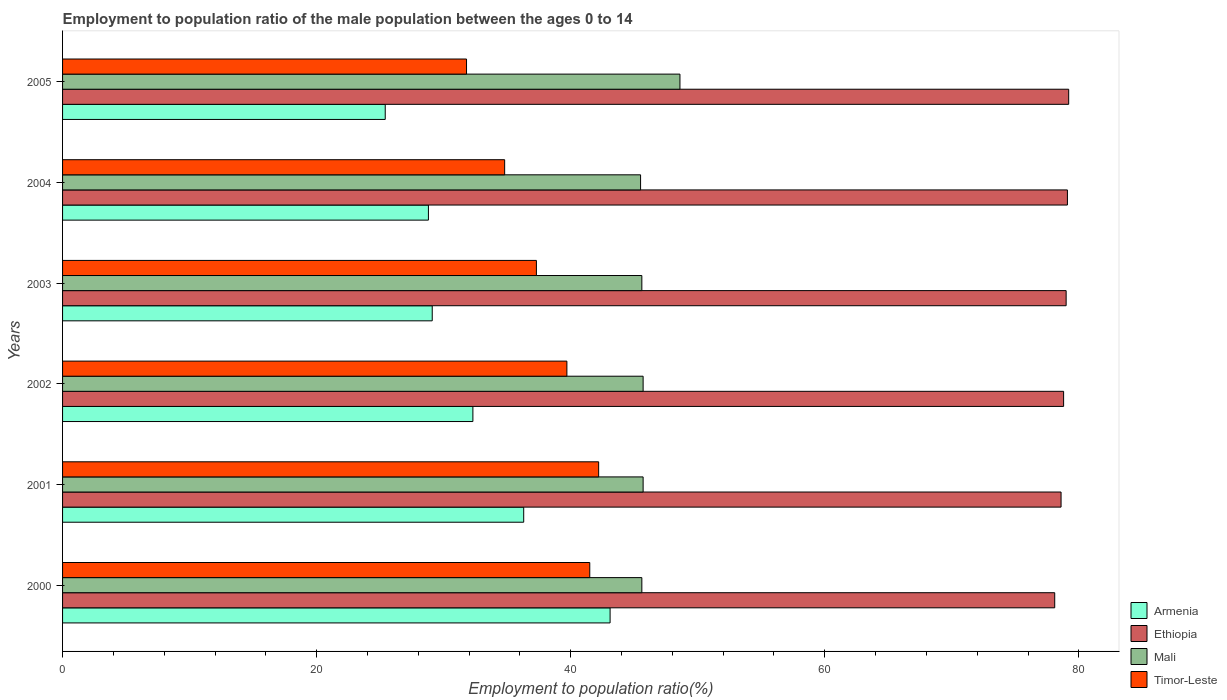How many different coloured bars are there?
Offer a very short reply. 4. How many groups of bars are there?
Offer a terse response. 6. Are the number of bars per tick equal to the number of legend labels?
Keep it short and to the point. Yes. How many bars are there on the 4th tick from the top?
Ensure brevity in your answer.  4. What is the label of the 2nd group of bars from the top?
Provide a succinct answer. 2004. What is the employment to population ratio in Armenia in 2004?
Keep it short and to the point. 28.8. Across all years, what is the maximum employment to population ratio in Armenia?
Your answer should be very brief. 43.1. Across all years, what is the minimum employment to population ratio in Armenia?
Offer a very short reply. 25.4. In which year was the employment to population ratio in Mali minimum?
Ensure brevity in your answer.  2004. What is the total employment to population ratio in Timor-Leste in the graph?
Provide a short and direct response. 227.3. What is the difference between the employment to population ratio in Timor-Leste in 2000 and that in 2002?
Give a very brief answer. 1.8. What is the difference between the employment to population ratio in Mali in 2005 and the employment to population ratio in Armenia in 2001?
Offer a terse response. 12.3. What is the average employment to population ratio in Timor-Leste per year?
Give a very brief answer. 37.88. In the year 2004, what is the difference between the employment to population ratio in Armenia and employment to population ratio in Ethiopia?
Offer a terse response. -50.3. What is the ratio of the employment to population ratio in Armenia in 2001 to that in 2005?
Provide a succinct answer. 1.43. What is the difference between the highest and the second highest employment to population ratio in Mali?
Your answer should be very brief. 2.9. What is the difference between the highest and the lowest employment to population ratio in Mali?
Provide a short and direct response. 3.1. In how many years, is the employment to population ratio in Mali greater than the average employment to population ratio in Mali taken over all years?
Offer a terse response. 1. Is the sum of the employment to population ratio in Armenia in 2002 and 2005 greater than the maximum employment to population ratio in Mali across all years?
Your response must be concise. Yes. Is it the case that in every year, the sum of the employment to population ratio in Timor-Leste and employment to population ratio in Mali is greater than the sum of employment to population ratio in Ethiopia and employment to population ratio in Armenia?
Keep it short and to the point. No. What does the 2nd bar from the top in 2004 represents?
Keep it short and to the point. Mali. What does the 1st bar from the bottom in 2001 represents?
Provide a short and direct response. Armenia. Is it the case that in every year, the sum of the employment to population ratio in Mali and employment to population ratio in Timor-Leste is greater than the employment to population ratio in Armenia?
Provide a succinct answer. Yes. Are all the bars in the graph horizontal?
Provide a succinct answer. Yes. How many years are there in the graph?
Provide a short and direct response. 6. Does the graph contain grids?
Your answer should be very brief. No. Where does the legend appear in the graph?
Provide a succinct answer. Bottom right. How many legend labels are there?
Offer a terse response. 4. How are the legend labels stacked?
Offer a very short reply. Vertical. What is the title of the graph?
Provide a short and direct response. Employment to population ratio of the male population between the ages 0 to 14. Does "Nicaragua" appear as one of the legend labels in the graph?
Offer a terse response. No. What is the label or title of the X-axis?
Make the answer very short. Employment to population ratio(%). What is the Employment to population ratio(%) of Armenia in 2000?
Make the answer very short. 43.1. What is the Employment to population ratio(%) in Ethiopia in 2000?
Provide a short and direct response. 78.1. What is the Employment to population ratio(%) in Mali in 2000?
Your answer should be very brief. 45.6. What is the Employment to population ratio(%) of Timor-Leste in 2000?
Your response must be concise. 41.5. What is the Employment to population ratio(%) of Armenia in 2001?
Give a very brief answer. 36.3. What is the Employment to population ratio(%) in Ethiopia in 2001?
Provide a short and direct response. 78.6. What is the Employment to population ratio(%) in Mali in 2001?
Make the answer very short. 45.7. What is the Employment to population ratio(%) of Timor-Leste in 2001?
Keep it short and to the point. 42.2. What is the Employment to population ratio(%) in Armenia in 2002?
Keep it short and to the point. 32.3. What is the Employment to population ratio(%) in Ethiopia in 2002?
Ensure brevity in your answer.  78.8. What is the Employment to population ratio(%) of Mali in 2002?
Make the answer very short. 45.7. What is the Employment to population ratio(%) of Timor-Leste in 2002?
Make the answer very short. 39.7. What is the Employment to population ratio(%) in Armenia in 2003?
Give a very brief answer. 29.1. What is the Employment to population ratio(%) in Ethiopia in 2003?
Your response must be concise. 79. What is the Employment to population ratio(%) of Mali in 2003?
Ensure brevity in your answer.  45.6. What is the Employment to population ratio(%) of Timor-Leste in 2003?
Give a very brief answer. 37.3. What is the Employment to population ratio(%) of Armenia in 2004?
Provide a succinct answer. 28.8. What is the Employment to population ratio(%) in Ethiopia in 2004?
Offer a terse response. 79.1. What is the Employment to population ratio(%) of Mali in 2004?
Provide a short and direct response. 45.5. What is the Employment to population ratio(%) in Timor-Leste in 2004?
Your response must be concise. 34.8. What is the Employment to population ratio(%) of Armenia in 2005?
Provide a succinct answer. 25.4. What is the Employment to population ratio(%) in Ethiopia in 2005?
Offer a terse response. 79.2. What is the Employment to population ratio(%) in Mali in 2005?
Ensure brevity in your answer.  48.6. What is the Employment to population ratio(%) in Timor-Leste in 2005?
Ensure brevity in your answer.  31.8. Across all years, what is the maximum Employment to population ratio(%) of Armenia?
Keep it short and to the point. 43.1. Across all years, what is the maximum Employment to population ratio(%) of Ethiopia?
Offer a very short reply. 79.2. Across all years, what is the maximum Employment to population ratio(%) of Mali?
Make the answer very short. 48.6. Across all years, what is the maximum Employment to population ratio(%) in Timor-Leste?
Your response must be concise. 42.2. Across all years, what is the minimum Employment to population ratio(%) in Armenia?
Make the answer very short. 25.4. Across all years, what is the minimum Employment to population ratio(%) in Ethiopia?
Offer a very short reply. 78.1. Across all years, what is the minimum Employment to population ratio(%) in Mali?
Your answer should be very brief. 45.5. Across all years, what is the minimum Employment to population ratio(%) of Timor-Leste?
Your answer should be compact. 31.8. What is the total Employment to population ratio(%) in Armenia in the graph?
Ensure brevity in your answer.  195. What is the total Employment to population ratio(%) in Ethiopia in the graph?
Give a very brief answer. 472.8. What is the total Employment to population ratio(%) of Mali in the graph?
Your answer should be very brief. 276.7. What is the total Employment to population ratio(%) of Timor-Leste in the graph?
Keep it short and to the point. 227.3. What is the difference between the Employment to population ratio(%) in Ethiopia in 2000 and that in 2001?
Your answer should be compact. -0.5. What is the difference between the Employment to population ratio(%) in Mali in 2000 and that in 2001?
Ensure brevity in your answer.  -0.1. What is the difference between the Employment to population ratio(%) in Ethiopia in 2000 and that in 2002?
Keep it short and to the point. -0.7. What is the difference between the Employment to population ratio(%) in Timor-Leste in 2000 and that in 2002?
Provide a short and direct response. 1.8. What is the difference between the Employment to population ratio(%) of Armenia in 2000 and that in 2003?
Offer a terse response. 14. What is the difference between the Employment to population ratio(%) of Timor-Leste in 2000 and that in 2003?
Ensure brevity in your answer.  4.2. What is the difference between the Employment to population ratio(%) of Armenia in 2000 and that in 2004?
Offer a very short reply. 14.3. What is the difference between the Employment to population ratio(%) in Ethiopia in 2000 and that in 2004?
Give a very brief answer. -1. What is the difference between the Employment to population ratio(%) in Mali in 2000 and that in 2004?
Give a very brief answer. 0.1. What is the difference between the Employment to population ratio(%) in Timor-Leste in 2000 and that in 2004?
Offer a very short reply. 6.7. What is the difference between the Employment to population ratio(%) in Armenia in 2000 and that in 2005?
Offer a very short reply. 17.7. What is the difference between the Employment to population ratio(%) in Mali in 2000 and that in 2005?
Provide a short and direct response. -3. What is the difference between the Employment to population ratio(%) in Timor-Leste in 2000 and that in 2005?
Provide a succinct answer. 9.7. What is the difference between the Employment to population ratio(%) in Armenia in 2001 and that in 2002?
Offer a terse response. 4. What is the difference between the Employment to population ratio(%) of Mali in 2001 and that in 2002?
Provide a short and direct response. 0. What is the difference between the Employment to population ratio(%) of Timor-Leste in 2001 and that in 2002?
Ensure brevity in your answer.  2.5. What is the difference between the Employment to population ratio(%) of Armenia in 2001 and that in 2003?
Provide a succinct answer. 7.2. What is the difference between the Employment to population ratio(%) of Ethiopia in 2001 and that in 2003?
Ensure brevity in your answer.  -0.4. What is the difference between the Employment to population ratio(%) of Timor-Leste in 2001 and that in 2003?
Offer a very short reply. 4.9. What is the difference between the Employment to population ratio(%) in Armenia in 2001 and that in 2004?
Give a very brief answer. 7.5. What is the difference between the Employment to population ratio(%) in Ethiopia in 2001 and that in 2004?
Keep it short and to the point. -0.5. What is the difference between the Employment to population ratio(%) in Timor-Leste in 2001 and that in 2004?
Provide a short and direct response. 7.4. What is the difference between the Employment to population ratio(%) of Armenia in 2001 and that in 2005?
Give a very brief answer. 10.9. What is the difference between the Employment to population ratio(%) of Ethiopia in 2001 and that in 2005?
Provide a short and direct response. -0.6. What is the difference between the Employment to population ratio(%) in Mali in 2001 and that in 2005?
Offer a terse response. -2.9. What is the difference between the Employment to population ratio(%) in Timor-Leste in 2001 and that in 2005?
Offer a very short reply. 10.4. What is the difference between the Employment to population ratio(%) in Armenia in 2002 and that in 2003?
Keep it short and to the point. 3.2. What is the difference between the Employment to population ratio(%) of Mali in 2002 and that in 2003?
Provide a succinct answer. 0.1. What is the difference between the Employment to population ratio(%) in Timor-Leste in 2002 and that in 2003?
Give a very brief answer. 2.4. What is the difference between the Employment to population ratio(%) of Armenia in 2002 and that in 2004?
Offer a very short reply. 3.5. What is the difference between the Employment to population ratio(%) of Ethiopia in 2002 and that in 2004?
Provide a short and direct response. -0.3. What is the difference between the Employment to population ratio(%) of Armenia in 2002 and that in 2005?
Make the answer very short. 6.9. What is the difference between the Employment to population ratio(%) of Mali in 2002 and that in 2005?
Your response must be concise. -2.9. What is the difference between the Employment to population ratio(%) in Timor-Leste in 2002 and that in 2005?
Make the answer very short. 7.9. What is the difference between the Employment to population ratio(%) of Armenia in 2003 and that in 2004?
Your response must be concise. 0.3. What is the difference between the Employment to population ratio(%) in Mali in 2003 and that in 2004?
Your answer should be compact. 0.1. What is the difference between the Employment to population ratio(%) of Ethiopia in 2003 and that in 2005?
Provide a short and direct response. -0.2. What is the difference between the Employment to population ratio(%) of Timor-Leste in 2003 and that in 2005?
Give a very brief answer. 5.5. What is the difference between the Employment to population ratio(%) in Ethiopia in 2004 and that in 2005?
Your answer should be very brief. -0.1. What is the difference between the Employment to population ratio(%) in Mali in 2004 and that in 2005?
Give a very brief answer. -3.1. What is the difference between the Employment to population ratio(%) in Armenia in 2000 and the Employment to population ratio(%) in Ethiopia in 2001?
Make the answer very short. -35.5. What is the difference between the Employment to population ratio(%) in Armenia in 2000 and the Employment to population ratio(%) in Mali in 2001?
Keep it short and to the point. -2.6. What is the difference between the Employment to population ratio(%) in Ethiopia in 2000 and the Employment to population ratio(%) in Mali in 2001?
Give a very brief answer. 32.4. What is the difference between the Employment to population ratio(%) in Ethiopia in 2000 and the Employment to population ratio(%) in Timor-Leste in 2001?
Provide a succinct answer. 35.9. What is the difference between the Employment to population ratio(%) in Mali in 2000 and the Employment to population ratio(%) in Timor-Leste in 2001?
Offer a very short reply. 3.4. What is the difference between the Employment to population ratio(%) in Armenia in 2000 and the Employment to population ratio(%) in Ethiopia in 2002?
Provide a succinct answer. -35.7. What is the difference between the Employment to population ratio(%) in Armenia in 2000 and the Employment to population ratio(%) in Mali in 2002?
Offer a terse response. -2.6. What is the difference between the Employment to population ratio(%) in Armenia in 2000 and the Employment to population ratio(%) in Timor-Leste in 2002?
Ensure brevity in your answer.  3.4. What is the difference between the Employment to population ratio(%) of Ethiopia in 2000 and the Employment to population ratio(%) of Mali in 2002?
Offer a terse response. 32.4. What is the difference between the Employment to population ratio(%) in Ethiopia in 2000 and the Employment to population ratio(%) in Timor-Leste in 2002?
Your answer should be compact. 38.4. What is the difference between the Employment to population ratio(%) in Armenia in 2000 and the Employment to population ratio(%) in Ethiopia in 2003?
Your response must be concise. -35.9. What is the difference between the Employment to population ratio(%) in Armenia in 2000 and the Employment to population ratio(%) in Timor-Leste in 2003?
Provide a succinct answer. 5.8. What is the difference between the Employment to population ratio(%) in Ethiopia in 2000 and the Employment to population ratio(%) in Mali in 2003?
Make the answer very short. 32.5. What is the difference between the Employment to population ratio(%) in Ethiopia in 2000 and the Employment to population ratio(%) in Timor-Leste in 2003?
Provide a short and direct response. 40.8. What is the difference between the Employment to population ratio(%) in Mali in 2000 and the Employment to population ratio(%) in Timor-Leste in 2003?
Make the answer very short. 8.3. What is the difference between the Employment to population ratio(%) of Armenia in 2000 and the Employment to population ratio(%) of Ethiopia in 2004?
Provide a succinct answer. -36. What is the difference between the Employment to population ratio(%) in Armenia in 2000 and the Employment to population ratio(%) in Mali in 2004?
Your answer should be compact. -2.4. What is the difference between the Employment to population ratio(%) of Ethiopia in 2000 and the Employment to population ratio(%) of Mali in 2004?
Offer a very short reply. 32.6. What is the difference between the Employment to population ratio(%) of Ethiopia in 2000 and the Employment to population ratio(%) of Timor-Leste in 2004?
Provide a succinct answer. 43.3. What is the difference between the Employment to population ratio(%) of Armenia in 2000 and the Employment to population ratio(%) of Ethiopia in 2005?
Offer a very short reply. -36.1. What is the difference between the Employment to population ratio(%) in Ethiopia in 2000 and the Employment to population ratio(%) in Mali in 2005?
Make the answer very short. 29.5. What is the difference between the Employment to population ratio(%) in Ethiopia in 2000 and the Employment to population ratio(%) in Timor-Leste in 2005?
Make the answer very short. 46.3. What is the difference between the Employment to population ratio(%) of Armenia in 2001 and the Employment to population ratio(%) of Ethiopia in 2002?
Your answer should be very brief. -42.5. What is the difference between the Employment to population ratio(%) in Ethiopia in 2001 and the Employment to population ratio(%) in Mali in 2002?
Offer a very short reply. 32.9. What is the difference between the Employment to population ratio(%) of Ethiopia in 2001 and the Employment to population ratio(%) of Timor-Leste in 2002?
Provide a succinct answer. 38.9. What is the difference between the Employment to population ratio(%) of Mali in 2001 and the Employment to population ratio(%) of Timor-Leste in 2002?
Offer a very short reply. 6. What is the difference between the Employment to population ratio(%) of Armenia in 2001 and the Employment to population ratio(%) of Ethiopia in 2003?
Your response must be concise. -42.7. What is the difference between the Employment to population ratio(%) of Armenia in 2001 and the Employment to population ratio(%) of Timor-Leste in 2003?
Provide a short and direct response. -1. What is the difference between the Employment to population ratio(%) of Ethiopia in 2001 and the Employment to population ratio(%) of Timor-Leste in 2003?
Your answer should be very brief. 41.3. What is the difference between the Employment to population ratio(%) in Mali in 2001 and the Employment to population ratio(%) in Timor-Leste in 2003?
Offer a very short reply. 8.4. What is the difference between the Employment to population ratio(%) of Armenia in 2001 and the Employment to population ratio(%) of Ethiopia in 2004?
Give a very brief answer. -42.8. What is the difference between the Employment to population ratio(%) in Armenia in 2001 and the Employment to population ratio(%) in Timor-Leste in 2004?
Your answer should be compact. 1.5. What is the difference between the Employment to population ratio(%) in Ethiopia in 2001 and the Employment to population ratio(%) in Mali in 2004?
Give a very brief answer. 33.1. What is the difference between the Employment to population ratio(%) of Ethiopia in 2001 and the Employment to population ratio(%) of Timor-Leste in 2004?
Provide a succinct answer. 43.8. What is the difference between the Employment to population ratio(%) in Armenia in 2001 and the Employment to population ratio(%) in Ethiopia in 2005?
Offer a very short reply. -42.9. What is the difference between the Employment to population ratio(%) of Armenia in 2001 and the Employment to population ratio(%) of Mali in 2005?
Give a very brief answer. -12.3. What is the difference between the Employment to population ratio(%) of Armenia in 2001 and the Employment to population ratio(%) of Timor-Leste in 2005?
Provide a succinct answer. 4.5. What is the difference between the Employment to population ratio(%) of Ethiopia in 2001 and the Employment to population ratio(%) of Mali in 2005?
Keep it short and to the point. 30. What is the difference between the Employment to population ratio(%) in Ethiopia in 2001 and the Employment to population ratio(%) in Timor-Leste in 2005?
Your answer should be very brief. 46.8. What is the difference between the Employment to population ratio(%) in Mali in 2001 and the Employment to population ratio(%) in Timor-Leste in 2005?
Your answer should be compact. 13.9. What is the difference between the Employment to population ratio(%) in Armenia in 2002 and the Employment to population ratio(%) in Ethiopia in 2003?
Your response must be concise. -46.7. What is the difference between the Employment to population ratio(%) of Armenia in 2002 and the Employment to population ratio(%) of Timor-Leste in 2003?
Your answer should be very brief. -5. What is the difference between the Employment to population ratio(%) of Ethiopia in 2002 and the Employment to population ratio(%) of Mali in 2003?
Your response must be concise. 33.2. What is the difference between the Employment to population ratio(%) of Ethiopia in 2002 and the Employment to population ratio(%) of Timor-Leste in 2003?
Your response must be concise. 41.5. What is the difference between the Employment to population ratio(%) in Mali in 2002 and the Employment to population ratio(%) in Timor-Leste in 2003?
Give a very brief answer. 8.4. What is the difference between the Employment to population ratio(%) in Armenia in 2002 and the Employment to population ratio(%) in Ethiopia in 2004?
Your answer should be compact. -46.8. What is the difference between the Employment to population ratio(%) of Armenia in 2002 and the Employment to population ratio(%) of Timor-Leste in 2004?
Provide a short and direct response. -2.5. What is the difference between the Employment to population ratio(%) in Ethiopia in 2002 and the Employment to population ratio(%) in Mali in 2004?
Offer a terse response. 33.3. What is the difference between the Employment to population ratio(%) of Armenia in 2002 and the Employment to population ratio(%) of Ethiopia in 2005?
Give a very brief answer. -46.9. What is the difference between the Employment to population ratio(%) of Armenia in 2002 and the Employment to population ratio(%) of Mali in 2005?
Provide a succinct answer. -16.3. What is the difference between the Employment to population ratio(%) of Armenia in 2002 and the Employment to population ratio(%) of Timor-Leste in 2005?
Provide a succinct answer. 0.5. What is the difference between the Employment to population ratio(%) of Ethiopia in 2002 and the Employment to population ratio(%) of Mali in 2005?
Offer a terse response. 30.2. What is the difference between the Employment to population ratio(%) of Armenia in 2003 and the Employment to population ratio(%) of Mali in 2004?
Give a very brief answer. -16.4. What is the difference between the Employment to population ratio(%) of Ethiopia in 2003 and the Employment to population ratio(%) of Mali in 2004?
Your response must be concise. 33.5. What is the difference between the Employment to population ratio(%) in Ethiopia in 2003 and the Employment to population ratio(%) in Timor-Leste in 2004?
Your answer should be compact. 44.2. What is the difference between the Employment to population ratio(%) of Mali in 2003 and the Employment to population ratio(%) of Timor-Leste in 2004?
Offer a terse response. 10.8. What is the difference between the Employment to population ratio(%) of Armenia in 2003 and the Employment to population ratio(%) of Ethiopia in 2005?
Your answer should be compact. -50.1. What is the difference between the Employment to population ratio(%) of Armenia in 2003 and the Employment to population ratio(%) of Mali in 2005?
Offer a very short reply. -19.5. What is the difference between the Employment to population ratio(%) of Ethiopia in 2003 and the Employment to population ratio(%) of Mali in 2005?
Provide a short and direct response. 30.4. What is the difference between the Employment to population ratio(%) of Ethiopia in 2003 and the Employment to population ratio(%) of Timor-Leste in 2005?
Provide a succinct answer. 47.2. What is the difference between the Employment to population ratio(%) of Mali in 2003 and the Employment to population ratio(%) of Timor-Leste in 2005?
Provide a succinct answer. 13.8. What is the difference between the Employment to population ratio(%) in Armenia in 2004 and the Employment to population ratio(%) in Ethiopia in 2005?
Make the answer very short. -50.4. What is the difference between the Employment to population ratio(%) in Armenia in 2004 and the Employment to population ratio(%) in Mali in 2005?
Make the answer very short. -19.8. What is the difference between the Employment to population ratio(%) in Ethiopia in 2004 and the Employment to population ratio(%) in Mali in 2005?
Offer a very short reply. 30.5. What is the difference between the Employment to population ratio(%) of Ethiopia in 2004 and the Employment to population ratio(%) of Timor-Leste in 2005?
Ensure brevity in your answer.  47.3. What is the average Employment to population ratio(%) of Armenia per year?
Offer a very short reply. 32.5. What is the average Employment to population ratio(%) in Ethiopia per year?
Your answer should be very brief. 78.8. What is the average Employment to population ratio(%) in Mali per year?
Provide a succinct answer. 46.12. What is the average Employment to population ratio(%) in Timor-Leste per year?
Make the answer very short. 37.88. In the year 2000, what is the difference between the Employment to population ratio(%) in Armenia and Employment to population ratio(%) in Ethiopia?
Your answer should be very brief. -35. In the year 2000, what is the difference between the Employment to population ratio(%) of Armenia and Employment to population ratio(%) of Timor-Leste?
Provide a succinct answer. 1.6. In the year 2000, what is the difference between the Employment to population ratio(%) in Ethiopia and Employment to population ratio(%) in Mali?
Make the answer very short. 32.5. In the year 2000, what is the difference between the Employment to population ratio(%) in Ethiopia and Employment to population ratio(%) in Timor-Leste?
Provide a short and direct response. 36.6. In the year 2001, what is the difference between the Employment to population ratio(%) of Armenia and Employment to population ratio(%) of Ethiopia?
Provide a succinct answer. -42.3. In the year 2001, what is the difference between the Employment to population ratio(%) of Armenia and Employment to population ratio(%) of Timor-Leste?
Provide a short and direct response. -5.9. In the year 2001, what is the difference between the Employment to population ratio(%) in Ethiopia and Employment to population ratio(%) in Mali?
Ensure brevity in your answer.  32.9. In the year 2001, what is the difference between the Employment to population ratio(%) of Ethiopia and Employment to population ratio(%) of Timor-Leste?
Your answer should be compact. 36.4. In the year 2001, what is the difference between the Employment to population ratio(%) in Mali and Employment to population ratio(%) in Timor-Leste?
Provide a short and direct response. 3.5. In the year 2002, what is the difference between the Employment to population ratio(%) of Armenia and Employment to population ratio(%) of Ethiopia?
Provide a short and direct response. -46.5. In the year 2002, what is the difference between the Employment to population ratio(%) of Armenia and Employment to population ratio(%) of Mali?
Provide a succinct answer. -13.4. In the year 2002, what is the difference between the Employment to population ratio(%) of Armenia and Employment to population ratio(%) of Timor-Leste?
Keep it short and to the point. -7.4. In the year 2002, what is the difference between the Employment to population ratio(%) in Ethiopia and Employment to population ratio(%) in Mali?
Provide a succinct answer. 33.1. In the year 2002, what is the difference between the Employment to population ratio(%) of Ethiopia and Employment to population ratio(%) of Timor-Leste?
Keep it short and to the point. 39.1. In the year 2003, what is the difference between the Employment to population ratio(%) in Armenia and Employment to population ratio(%) in Ethiopia?
Provide a short and direct response. -49.9. In the year 2003, what is the difference between the Employment to population ratio(%) of Armenia and Employment to population ratio(%) of Mali?
Give a very brief answer. -16.5. In the year 2003, what is the difference between the Employment to population ratio(%) in Armenia and Employment to population ratio(%) in Timor-Leste?
Your answer should be compact. -8.2. In the year 2003, what is the difference between the Employment to population ratio(%) of Ethiopia and Employment to population ratio(%) of Mali?
Offer a very short reply. 33.4. In the year 2003, what is the difference between the Employment to population ratio(%) of Ethiopia and Employment to population ratio(%) of Timor-Leste?
Make the answer very short. 41.7. In the year 2003, what is the difference between the Employment to population ratio(%) of Mali and Employment to population ratio(%) of Timor-Leste?
Offer a very short reply. 8.3. In the year 2004, what is the difference between the Employment to population ratio(%) in Armenia and Employment to population ratio(%) in Ethiopia?
Ensure brevity in your answer.  -50.3. In the year 2004, what is the difference between the Employment to population ratio(%) in Armenia and Employment to population ratio(%) in Mali?
Keep it short and to the point. -16.7. In the year 2004, what is the difference between the Employment to population ratio(%) of Armenia and Employment to population ratio(%) of Timor-Leste?
Make the answer very short. -6. In the year 2004, what is the difference between the Employment to population ratio(%) of Ethiopia and Employment to population ratio(%) of Mali?
Offer a very short reply. 33.6. In the year 2004, what is the difference between the Employment to population ratio(%) in Ethiopia and Employment to population ratio(%) in Timor-Leste?
Ensure brevity in your answer.  44.3. In the year 2005, what is the difference between the Employment to population ratio(%) in Armenia and Employment to population ratio(%) in Ethiopia?
Offer a very short reply. -53.8. In the year 2005, what is the difference between the Employment to population ratio(%) in Armenia and Employment to population ratio(%) in Mali?
Your answer should be very brief. -23.2. In the year 2005, what is the difference between the Employment to population ratio(%) in Ethiopia and Employment to population ratio(%) in Mali?
Ensure brevity in your answer.  30.6. In the year 2005, what is the difference between the Employment to population ratio(%) of Ethiopia and Employment to population ratio(%) of Timor-Leste?
Provide a short and direct response. 47.4. In the year 2005, what is the difference between the Employment to population ratio(%) in Mali and Employment to population ratio(%) in Timor-Leste?
Provide a short and direct response. 16.8. What is the ratio of the Employment to population ratio(%) of Armenia in 2000 to that in 2001?
Offer a very short reply. 1.19. What is the ratio of the Employment to population ratio(%) in Mali in 2000 to that in 2001?
Your answer should be very brief. 1. What is the ratio of the Employment to population ratio(%) of Timor-Leste in 2000 to that in 2001?
Provide a short and direct response. 0.98. What is the ratio of the Employment to population ratio(%) in Armenia in 2000 to that in 2002?
Make the answer very short. 1.33. What is the ratio of the Employment to population ratio(%) of Mali in 2000 to that in 2002?
Ensure brevity in your answer.  1. What is the ratio of the Employment to population ratio(%) of Timor-Leste in 2000 to that in 2002?
Offer a very short reply. 1.05. What is the ratio of the Employment to population ratio(%) in Armenia in 2000 to that in 2003?
Offer a terse response. 1.48. What is the ratio of the Employment to population ratio(%) of Ethiopia in 2000 to that in 2003?
Offer a very short reply. 0.99. What is the ratio of the Employment to population ratio(%) in Timor-Leste in 2000 to that in 2003?
Ensure brevity in your answer.  1.11. What is the ratio of the Employment to population ratio(%) in Armenia in 2000 to that in 2004?
Your answer should be very brief. 1.5. What is the ratio of the Employment to population ratio(%) in Ethiopia in 2000 to that in 2004?
Your answer should be very brief. 0.99. What is the ratio of the Employment to population ratio(%) of Mali in 2000 to that in 2004?
Give a very brief answer. 1. What is the ratio of the Employment to population ratio(%) in Timor-Leste in 2000 to that in 2004?
Your answer should be compact. 1.19. What is the ratio of the Employment to population ratio(%) of Armenia in 2000 to that in 2005?
Keep it short and to the point. 1.7. What is the ratio of the Employment to population ratio(%) in Ethiopia in 2000 to that in 2005?
Give a very brief answer. 0.99. What is the ratio of the Employment to population ratio(%) in Mali in 2000 to that in 2005?
Give a very brief answer. 0.94. What is the ratio of the Employment to population ratio(%) of Timor-Leste in 2000 to that in 2005?
Your answer should be very brief. 1.3. What is the ratio of the Employment to population ratio(%) in Armenia in 2001 to that in 2002?
Your answer should be very brief. 1.12. What is the ratio of the Employment to population ratio(%) in Ethiopia in 2001 to that in 2002?
Ensure brevity in your answer.  1. What is the ratio of the Employment to population ratio(%) of Timor-Leste in 2001 to that in 2002?
Keep it short and to the point. 1.06. What is the ratio of the Employment to population ratio(%) of Armenia in 2001 to that in 2003?
Offer a terse response. 1.25. What is the ratio of the Employment to population ratio(%) in Timor-Leste in 2001 to that in 2003?
Give a very brief answer. 1.13. What is the ratio of the Employment to population ratio(%) of Armenia in 2001 to that in 2004?
Your answer should be very brief. 1.26. What is the ratio of the Employment to population ratio(%) of Mali in 2001 to that in 2004?
Your answer should be compact. 1. What is the ratio of the Employment to population ratio(%) in Timor-Leste in 2001 to that in 2004?
Keep it short and to the point. 1.21. What is the ratio of the Employment to population ratio(%) in Armenia in 2001 to that in 2005?
Offer a terse response. 1.43. What is the ratio of the Employment to population ratio(%) of Ethiopia in 2001 to that in 2005?
Provide a short and direct response. 0.99. What is the ratio of the Employment to population ratio(%) in Mali in 2001 to that in 2005?
Provide a short and direct response. 0.94. What is the ratio of the Employment to population ratio(%) of Timor-Leste in 2001 to that in 2005?
Offer a very short reply. 1.33. What is the ratio of the Employment to population ratio(%) in Armenia in 2002 to that in 2003?
Ensure brevity in your answer.  1.11. What is the ratio of the Employment to population ratio(%) in Mali in 2002 to that in 2003?
Offer a terse response. 1. What is the ratio of the Employment to population ratio(%) of Timor-Leste in 2002 to that in 2003?
Make the answer very short. 1.06. What is the ratio of the Employment to population ratio(%) in Armenia in 2002 to that in 2004?
Your answer should be very brief. 1.12. What is the ratio of the Employment to population ratio(%) of Timor-Leste in 2002 to that in 2004?
Ensure brevity in your answer.  1.14. What is the ratio of the Employment to population ratio(%) of Armenia in 2002 to that in 2005?
Offer a very short reply. 1.27. What is the ratio of the Employment to population ratio(%) in Ethiopia in 2002 to that in 2005?
Ensure brevity in your answer.  0.99. What is the ratio of the Employment to population ratio(%) of Mali in 2002 to that in 2005?
Offer a terse response. 0.94. What is the ratio of the Employment to population ratio(%) in Timor-Leste in 2002 to that in 2005?
Make the answer very short. 1.25. What is the ratio of the Employment to population ratio(%) of Armenia in 2003 to that in 2004?
Your answer should be very brief. 1.01. What is the ratio of the Employment to population ratio(%) of Mali in 2003 to that in 2004?
Ensure brevity in your answer.  1. What is the ratio of the Employment to population ratio(%) of Timor-Leste in 2003 to that in 2004?
Give a very brief answer. 1.07. What is the ratio of the Employment to population ratio(%) in Armenia in 2003 to that in 2005?
Your answer should be compact. 1.15. What is the ratio of the Employment to population ratio(%) in Ethiopia in 2003 to that in 2005?
Your answer should be very brief. 1. What is the ratio of the Employment to population ratio(%) of Mali in 2003 to that in 2005?
Your answer should be compact. 0.94. What is the ratio of the Employment to population ratio(%) in Timor-Leste in 2003 to that in 2005?
Provide a short and direct response. 1.17. What is the ratio of the Employment to population ratio(%) in Armenia in 2004 to that in 2005?
Keep it short and to the point. 1.13. What is the ratio of the Employment to population ratio(%) in Ethiopia in 2004 to that in 2005?
Your answer should be very brief. 1. What is the ratio of the Employment to population ratio(%) in Mali in 2004 to that in 2005?
Offer a terse response. 0.94. What is the ratio of the Employment to population ratio(%) in Timor-Leste in 2004 to that in 2005?
Your answer should be compact. 1.09. What is the difference between the highest and the second highest Employment to population ratio(%) in Armenia?
Provide a short and direct response. 6.8. What is the difference between the highest and the second highest Employment to population ratio(%) of Ethiopia?
Your answer should be very brief. 0.1. What is the difference between the highest and the second highest Employment to population ratio(%) in Mali?
Make the answer very short. 2.9. What is the difference between the highest and the second highest Employment to population ratio(%) in Timor-Leste?
Provide a short and direct response. 0.7. What is the difference between the highest and the lowest Employment to population ratio(%) in Mali?
Offer a terse response. 3.1. What is the difference between the highest and the lowest Employment to population ratio(%) of Timor-Leste?
Provide a short and direct response. 10.4. 